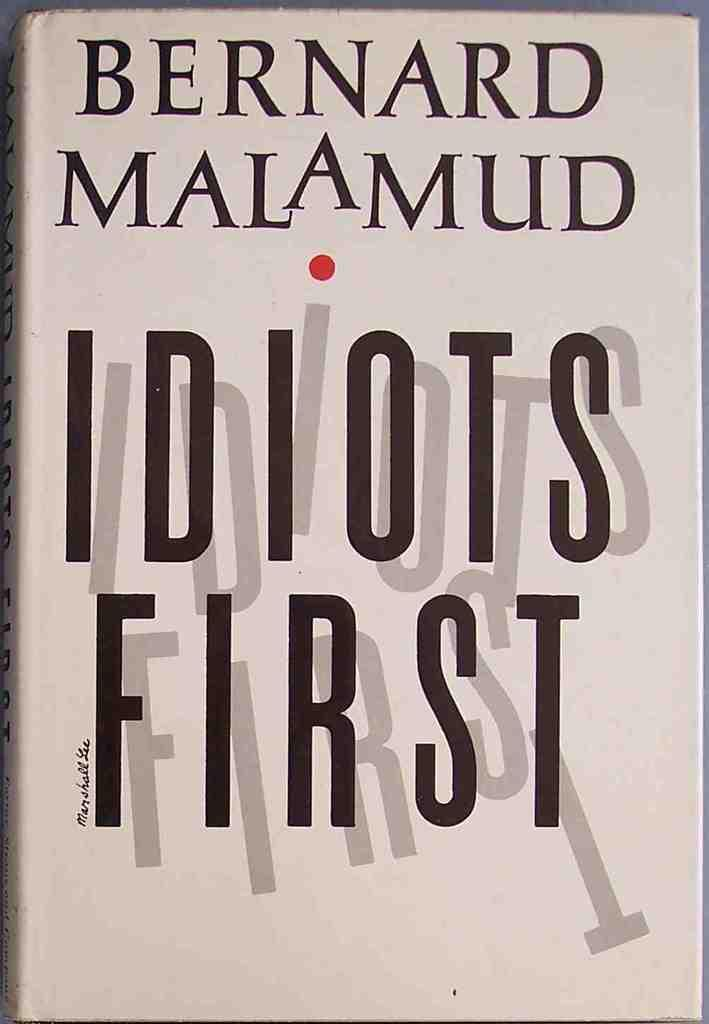<image>
Relay a brief, clear account of the picture shown. The white cover of a book written by Bernard Malamud called "Idiots First" is shown. 